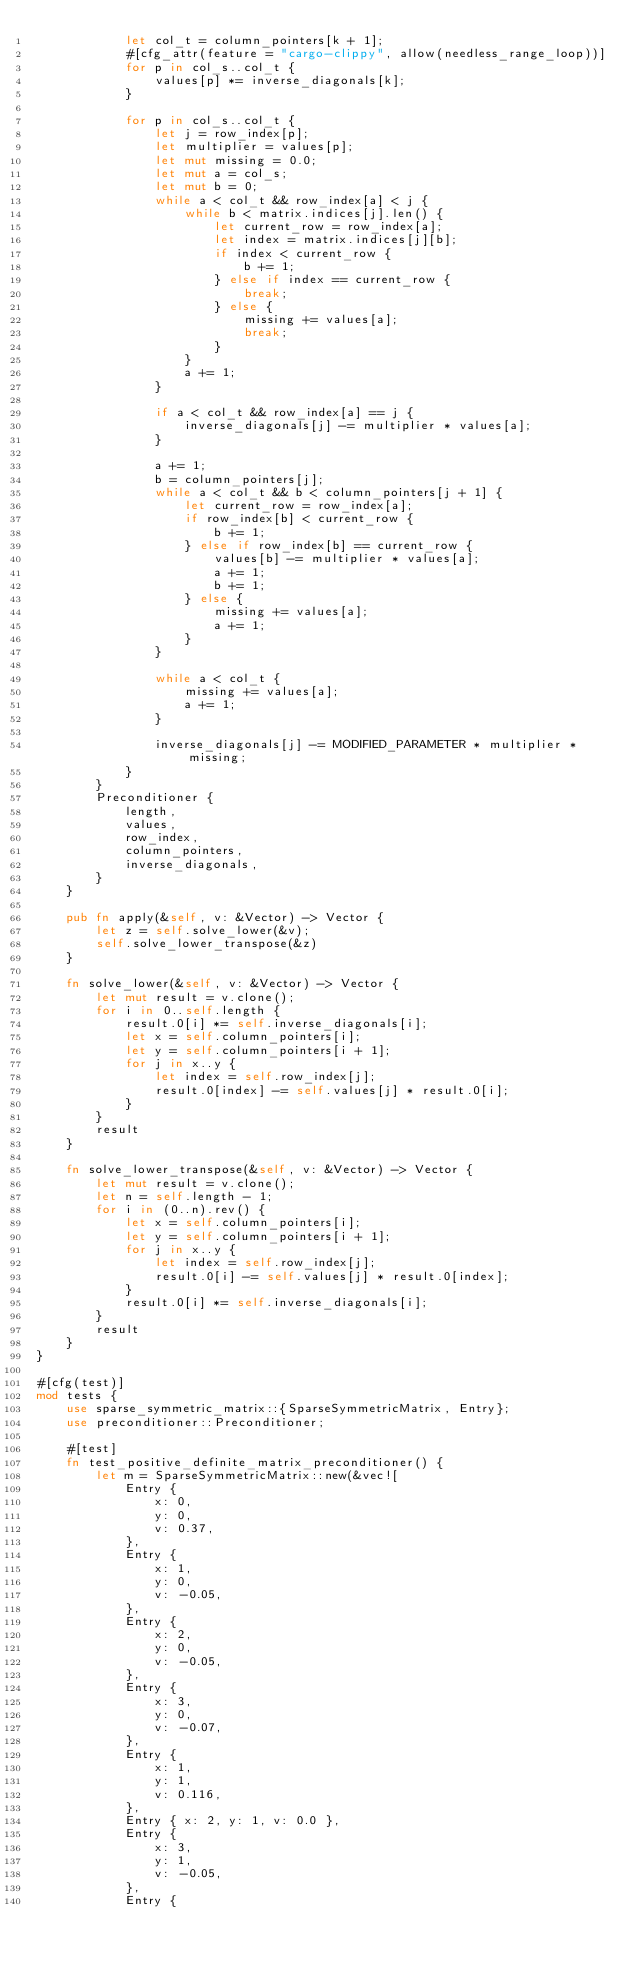Convert code to text. <code><loc_0><loc_0><loc_500><loc_500><_Rust_>            let col_t = column_pointers[k + 1];
            #[cfg_attr(feature = "cargo-clippy", allow(needless_range_loop))]
            for p in col_s..col_t {
                values[p] *= inverse_diagonals[k];
            }

            for p in col_s..col_t {
                let j = row_index[p];
                let multiplier = values[p];
                let mut missing = 0.0;
                let mut a = col_s;
                let mut b = 0;
                while a < col_t && row_index[a] < j {
                    while b < matrix.indices[j].len() {
                        let current_row = row_index[a];
                        let index = matrix.indices[j][b];
                        if index < current_row {
                            b += 1;
                        } else if index == current_row {
                            break;
                        } else {
                            missing += values[a];
                            break;
                        }
                    }
                    a += 1;
                }

                if a < col_t && row_index[a] == j {
                    inverse_diagonals[j] -= multiplier * values[a];
                }

                a += 1;
                b = column_pointers[j];
                while a < col_t && b < column_pointers[j + 1] {
                    let current_row = row_index[a];
                    if row_index[b] < current_row {
                        b += 1;
                    } else if row_index[b] == current_row {
                        values[b] -= multiplier * values[a];
                        a += 1;
                        b += 1;
                    } else {
                        missing += values[a];
                        a += 1;
                    }
                }

                while a < col_t {
                    missing += values[a];
                    a += 1;
                }

                inverse_diagonals[j] -= MODIFIED_PARAMETER * multiplier * missing;
            }
        }
        Preconditioner {
            length,
            values,
            row_index,
            column_pointers,
            inverse_diagonals,
        }
    }

    pub fn apply(&self, v: &Vector) -> Vector {
        let z = self.solve_lower(&v);
        self.solve_lower_transpose(&z)
    }

    fn solve_lower(&self, v: &Vector) -> Vector {
        let mut result = v.clone();
        for i in 0..self.length {
            result.0[i] *= self.inverse_diagonals[i];
            let x = self.column_pointers[i];
            let y = self.column_pointers[i + 1];
            for j in x..y {
                let index = self.row_index[j];
                result.0[index] -= self.values[j] * result.0[i];
            }
        }
        result
    }

    fn solve_lower_transpose(&self, v: &Vector) -> Vector {
        let mut result = v.clone();
        let n = self.length - 1;
        for i in (0..n).rev() {
            let x = self.column_pointers[i];
            let y = self.column_pointers[i + 1];
            for j in x..y {
                let index = self.row_index[j];
                result.0[i] -= self.values[j] * result.0[index];
            }
            result.0[i] *= self.inverse_diagonals[i];
        }
        result
    }
}

#[cfg(test)]
mod tests {
    use sparse_symmetric_matrix::{SparseSymmetricMatrix, Entry};
    use preconditioner::Preconditioner;

    #[test]
    fn test_positive_definite_matrix_preconditioner() {
        let m = SparseSymmetricMatrix::new(&vec![
            Entry {
                x: 0,
                y: 0,
                v: 0.37,
            },
            Entry {
                x: 1,
                y: 0,
                v: -0.05,
            },
            Entry {
                x: 2,
                y: 0,
                v: -0.05,
            },
            Entry {
                x: 3,
                y: 0,
                v: -0.07,
            },
            Entry {
                x: 1,
                y: 1,
                v: 0.116,
            },
            Entry { x: 2, y: 1, v: 0.0 },
            Entry {
                x: 3,
                y: 1,
                v: -0.05,
            },
            Entry {</code> 